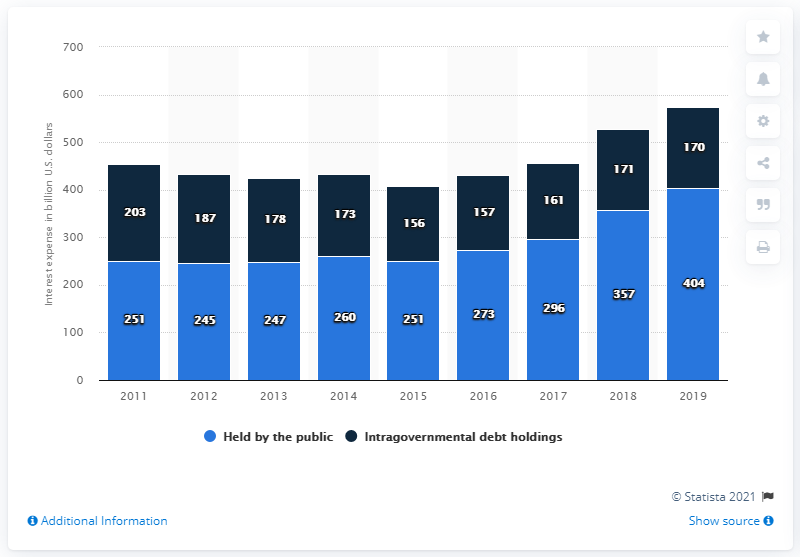Identify some key points in this picture. The highest value in the blue bar is 404. The U.S. Government spent approximately $404 billion on interest for debt held by the public in 2019. The total interest expenses in 2019 were 574... 